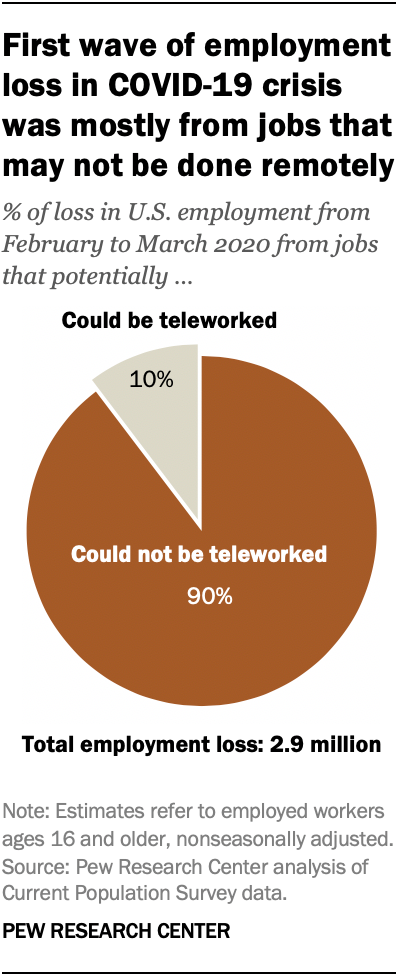Point out several critical features in this image. The ratio of the smallest and largest segments in the given decimal is approximately 0.047916667. The color of the smallest segment is gray. 